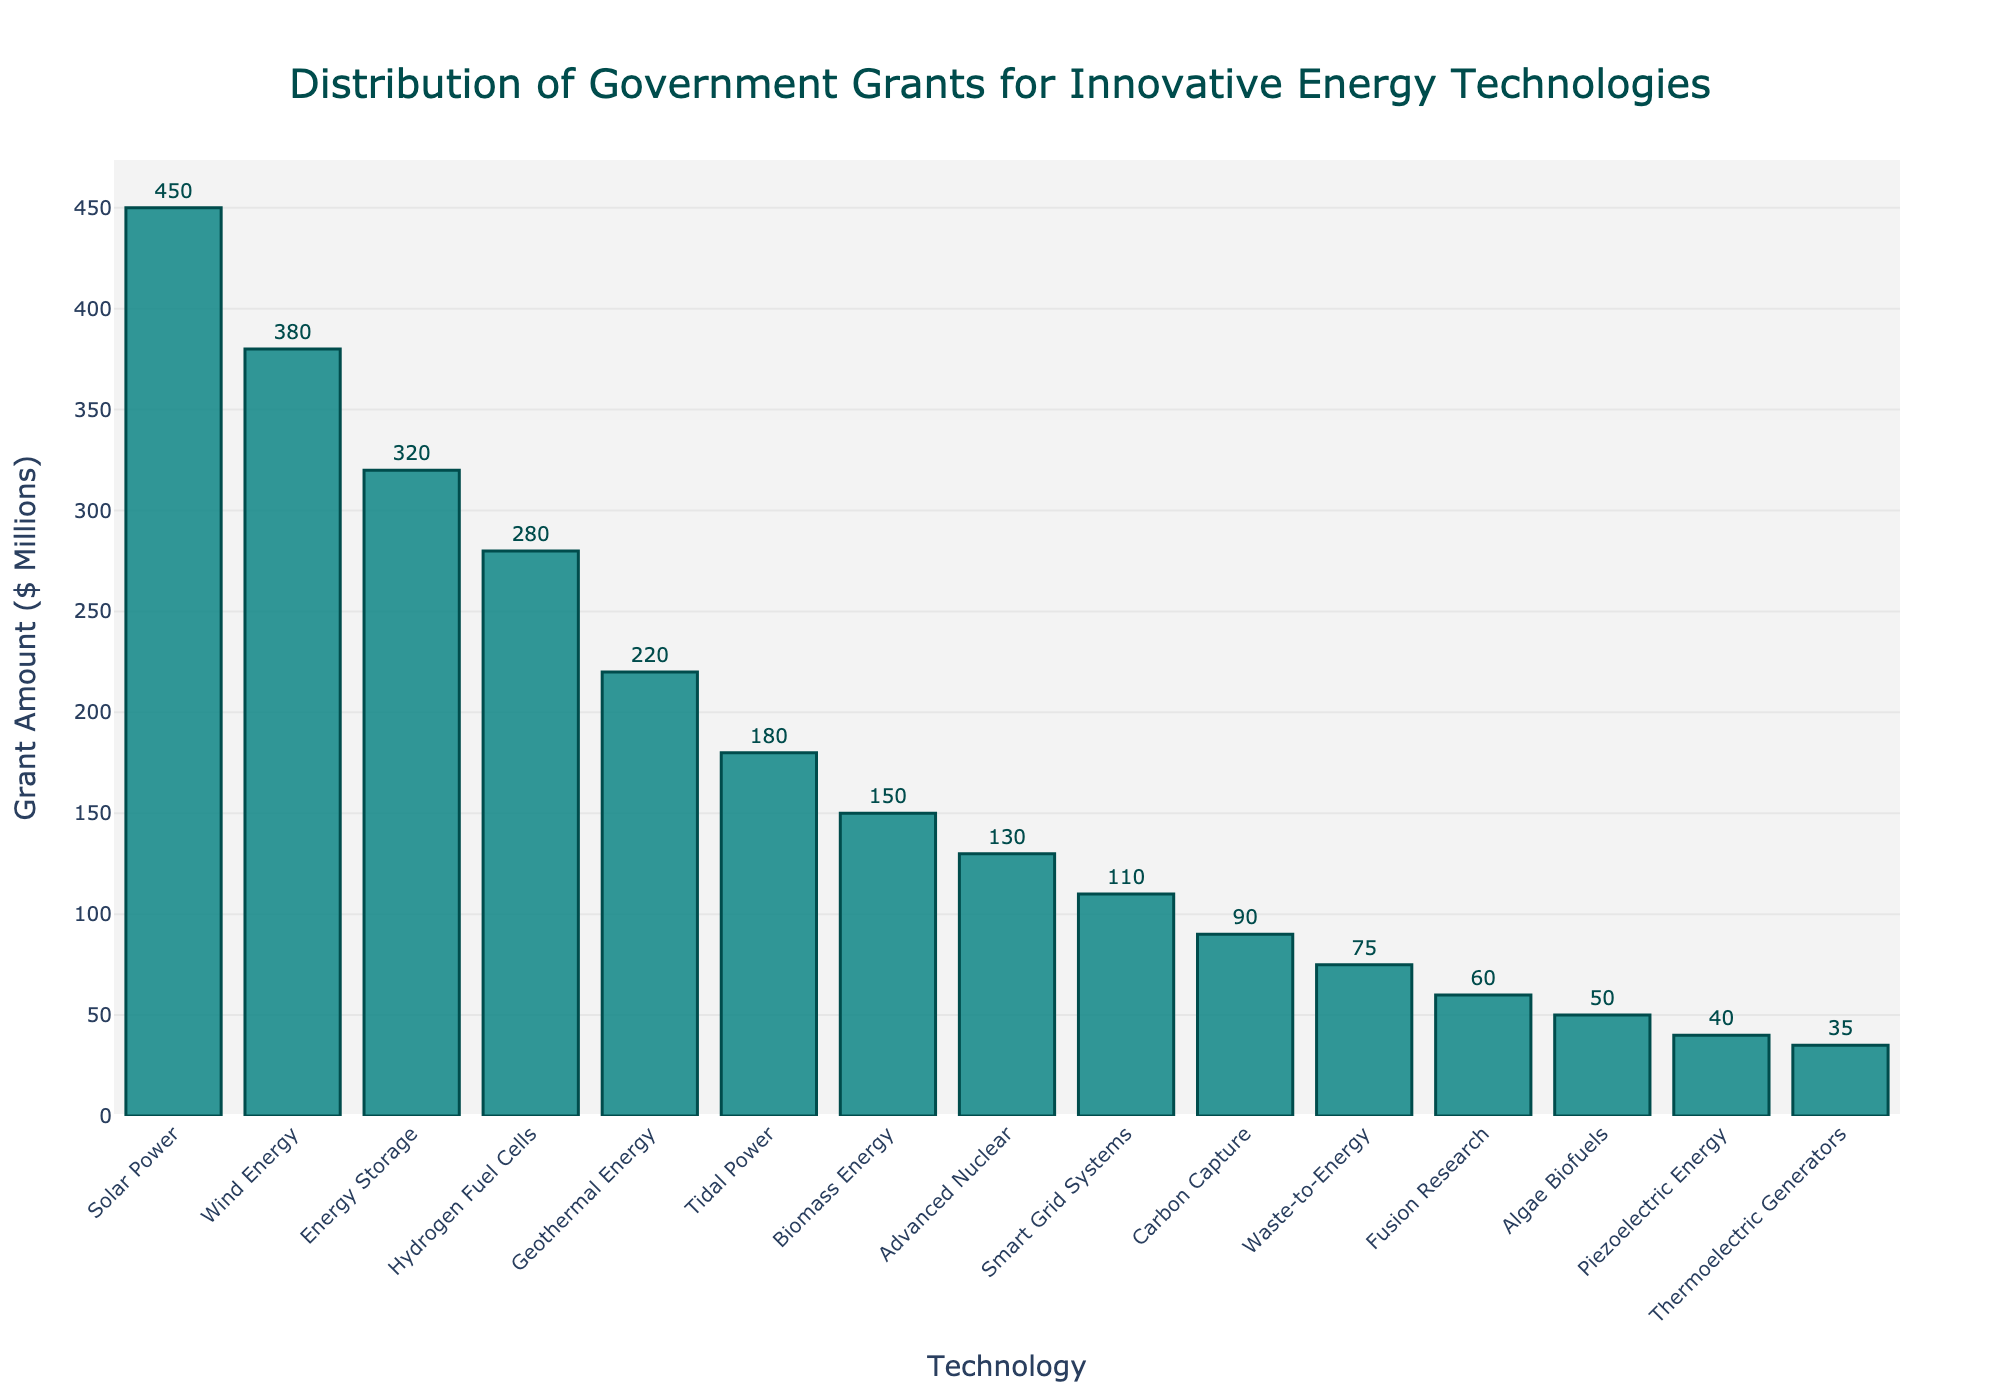Which technology received the highest grant amount? The tallest bar on the chart represents the technology that received the highest grant amount. By examining the chart, we see that Solar Power has the highest bar.
Answer: Solar Power Which technology received the lowest grant amount? The shortest bar on the chart represents the technology that received the lowest grant amount. By examining the chart, we see that Thermoelectric Generators has the lowest bar.
Answer: Thermoelectric Generators What is the combined grant amount for Wind Energy and Solar Power? To find the combined grant amount, add the grant amounts given to Wind Energy and Solar Power. Wind Energy received $380 million, and Solar Power received $450 million. Therefore, the total is 380 + 450 = 830.
Answer: $830 million Which technology received more funding: Energy Storage or Hydrogen Fuel Cells? By examining the height of the bars for Energy Storage and Hydrogen Fuel Cells, we compare their heights. Energy Storage has a taller bar than Hydrogen Fuel Cells.
Answer: Energy Storage How many technologies received grants greater than $300 million? Count the number of bars that surpass the $300 million mark on the y-axis. Solar Power, Wind Energy, and Energy Storage exceed $300 million.
Answer: 3 What is the average grant amount for the technologies shown? Sum all the grant amounts and divide by the number of technologies. The total grant amount is 450 + 380 + 320 + 280 + 220 + 180 + 150 + 130 + 110 + 90 + 75 + 60 + 50 + 40 + 35 = 2560 million. There are 15 technologies. The average is 2560 / 15 ≈ 170.67.
Answer: $170.67 million How does the grant amount for Tidal Power compare to Geothermal Energy? Compare the heights of the bars for Tidal Power and Geothermal Energy. Tidal Power has a shorter bar than Geothermal Energy.
Answer: Less What is the difference in funding between the highest and the lowest funded technologies? Subtract the grant amount of the lowest funded technology (Thermoelectric Generators) from the highest funded technology (Solar Power). The difference is 450 - 35 = 415.
Answer: $415 million Which technology has a grant amount closest to the median grant amount? First, order the grant amounts and find the middle value. The ordered grants are 35, 40, 50, 60, 75, 90, 110, 130, 150, 180, 220, 280, 320, 380, 450. The median is the 8th value: 130 (Advanced Nuclear).
Answer: Advanced Nuclear What proportion of the total grant amount was given to Smart Grid Systems? Calculate the ratio of the grant amount for Smart Grid Systems to the total grant amount. Smart Grid Systems received $110 million, and the total is $2560 million. The proportion is 110 / 2560 ≈ 0.04296875.
Answer: 4.3% 